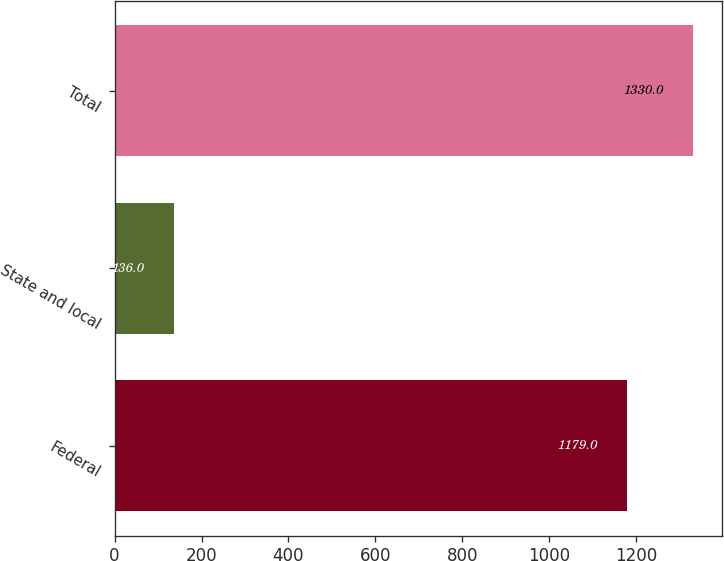Convert chart. <chart><loc_0><loc_0><loc_500><loc_500><bar_chart><fcel>Federal<fcel>State and local<fcel>Total<nl><fcel>1179<fcel>136<fcel>1330<nl></chart> 